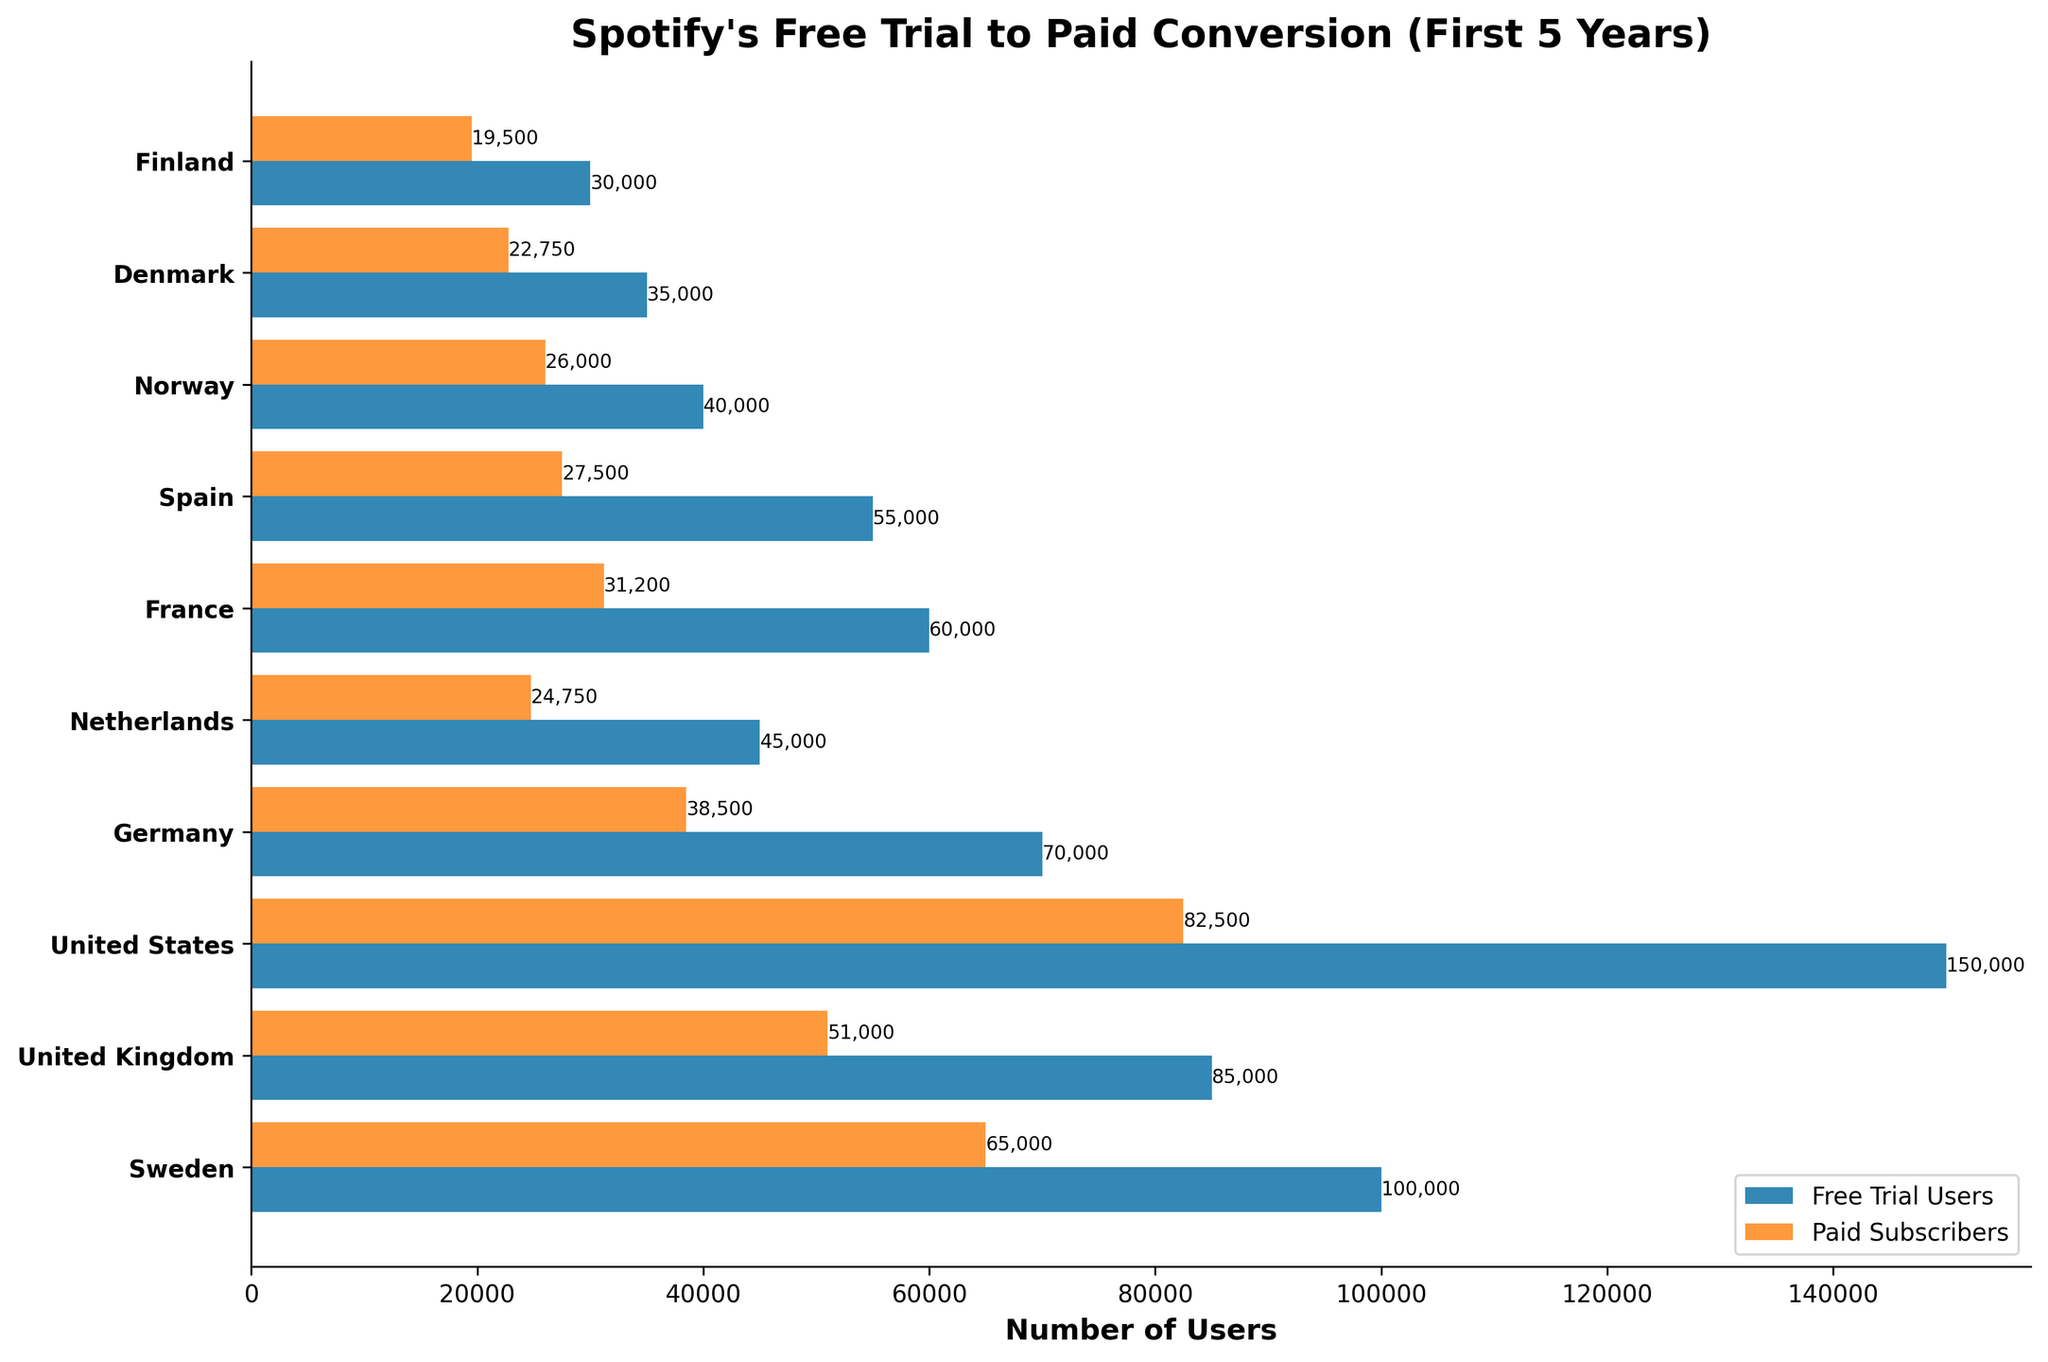What is the title of the chart? The title is located at the top of the chart and is written in a larger and bold font to indicate the main subject of the chart.
Answer: Spotify's Free Trial to Paid Conversion (First 5 Years) How many countries are represented in the chart? By counting the number of country names listed on the y-axis of the chart.
Answer: 10 Which country had the highest number of free trial users? Look at the length of the bars on the free trial users (the top set of bars). The country with the longest bar has the highest number.
Answer: United States Which country had the highest conversion rate to paid subscribers? Calculate the conversion rate for each country by dividing the number of paid subscribers by the number of free trial users and then compare the rates.
Answer: Norway What is the difference in the number of paid subscribers between the United States and the United Kingdom? Subtract the number of paid subscribers in the United Kingdom from the number of paid subscribers in the United States.
Answer: 31,500 What was the average number of paid subscribers across the countries? Add the paid subscribers for all countries and divide by the number of countries. (65,000 + 51,000 + 82,500 + 38,500 + 24,750 + 31,200 + 27,500 + 26,000 + 22,750 + 19,500) / 10 = 38,270
Answer: 38,270 Which country had the smallest gap between the number of free trial users and paid subscribers? Calculate the difference for each country and then find the smallest one. Difference = Free Trial Users - Paid Subscribers.
Answer: Denmark How does the number of paid subscribers in Germany compare to that in France? Compare the lengths of the paid subscriber bars for Germany and France.
Answer: Germany has more paid subscribers than France What is the combined total of free trial users for the Nordic countries (Sweden, Norway, Denmark, Finland)? Add the number of free trial users for Sweden, Norway, Denmark, and Finland. (100,000 + 40,000 + 35,000 + 30,000)
Answer: 205,000 Which country had the lowest number of free trial users? Identify the country with the shortest bar in the free trial users section.
Answer: Finland 